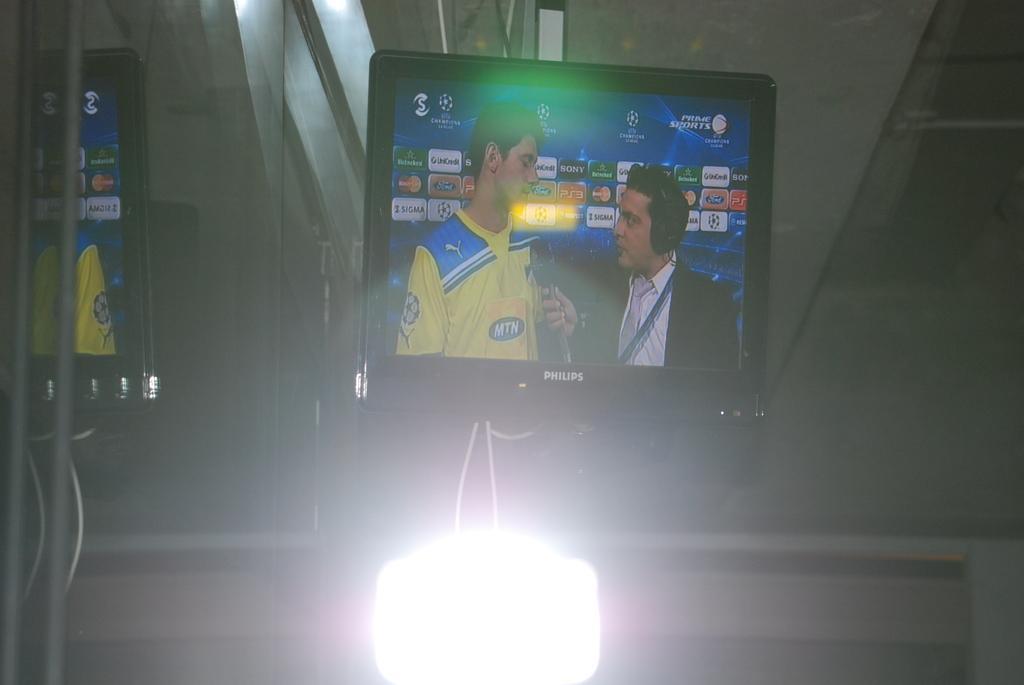<image>
Write a terse but informative summary of the picture. Philips monitor with one guy interviewing an athlete. 